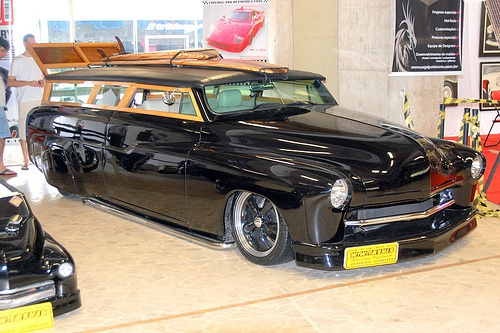Describe the objects in this image and their specific colors. I can see car in lightgray, black, gray, and maroon tones, car in lightgray, black, gray, and darkgray tones, people in lightgray, lightpink, tan, and darkgray tones, surfboard in lightgray, tan, and gray tones, and surfboard in lightgray, tan, brown, and maroon tones in this image. 